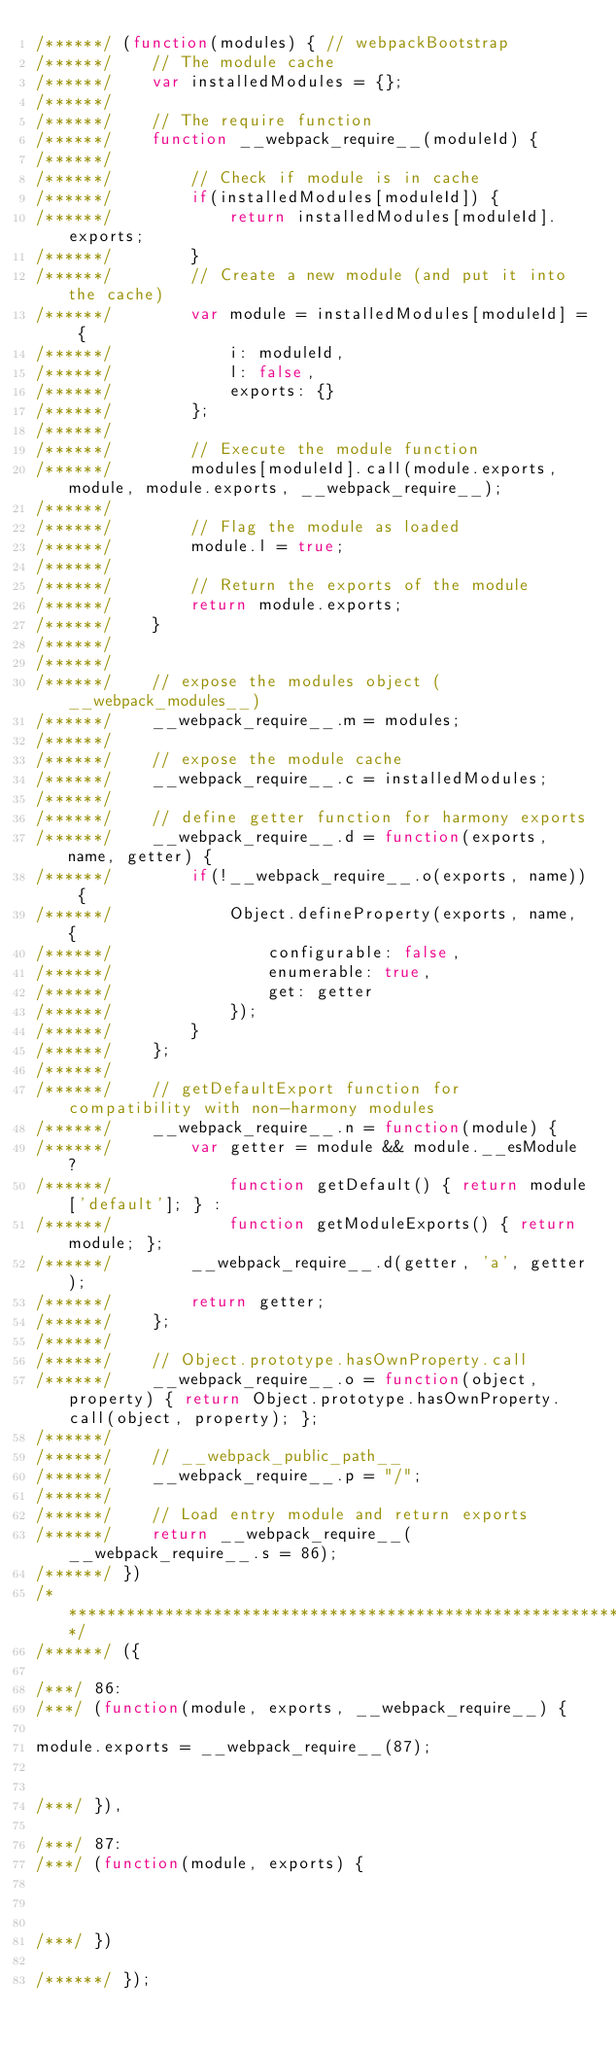Convert code to text. <code><loc_0><loc_0><loc_500><loc_500><_JavaScript_>/******/ (function(modules) { // webpackBootstrap
/******/ 	// The module cache
/******/ 	var installedModules = {};
/******/
/******/ 	// The require function
/******/ 	function __webpack_require__(moduleId) {
/******/
/******/ 		// Check if module is in cache
/******/ 		if(installedModules[moduleId]) {
/******/ 			return installedModules[moduleId].exports;
/******/ 		}
/******/ 		// Create a new module (and put it into the cache)
/******/ 		var module = installedModules[moduleId] = {
/******/ 			i: moduleId,
/******/ 			l: false,
/******/ 			exports: {}
/******/ 		};
/******/
/******/ 		// Execute the module function
/******/ 		modules[moduleId].call(module.exports, module, module.exports, __webpack_require__);
/******/
/******/ 		// Flag the module as loaded
/******/ 		module.l = true;
/******/
/******/ 		// Return the exports of the module
/******/ 		return module.exports;
/******/ 	}
/******/
/******/
/******/ 	// expose the modules object (__webpack_modules__)
/******/ 	__webpack_require__.m = modules;
/******/
/******/ 	// expose the module cache
/******/ 	__webpack_require__.c = installedModules;
/******/
/******/ 	// define getter function for harmony exports
/******/ 	__webpack_require__.d = function(exports, name, getter) {
/******/ 		if(!__webpack_require__.o(exports, name)) {
/******/ 			Object.defineProperty(exports, name, {
/******/ 				configurable: false,
/******/ 				enumerable: true,
/******/ 				get: getter
/******/ 			});
/******/ 		}
/******/ 	};
/******/
/******/ 	// getDefaultExport function for compatibility with non-harmony modules
/******/ 	__webpack_require__.n = function(module) {
/******/ 		var getter = module && module.__esModule ?
/******/ 			function getDefault() { return module['default']; } :
/******/ 			function getModuleExports() { return module; };
/******/ 		__webpack_require__.d(getter, 'a', getter);
/******/ 		return getter;
/******/ 	};
/******/
/******/ 	// Object.prototype.hasOwnProperty.call
/******/ 	__webpack_require__.o = function(object, property) { return Object.prototype.hasOwnProperty.call(object, property); };
/******/
/******/ 	// __webpack_public_path__
/******/ 	__webpack_require__.p = "/";
/******/
/******/ 	// Load entry module and return exports
/******/ 	return __webpack_require__(__webpack_require__.s = 86);
/******/ })
/************************************************************************/
/******/ ({

/***/ 86:
/***/ (function(module, exports, __webpack_require__) {

module.exports = __webpack_require__(87);


/***/ }),

/***/ 87:
/***/ (function(module, exports) {



/***/ })

/******/ });</code> 